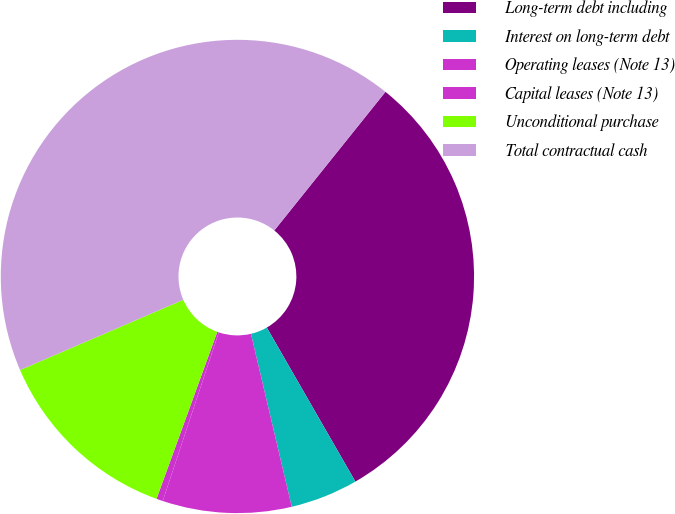<chart> <loc_0><loc_0><loc_500><loc_500><pie_chart><fcel>Long-term debt including<fcel>Interest on long-term debt<fcel>Operating leases (Note 13)<fcel>Capital leases (Note 13)<fcel>Unconditional purchase<fcel>Total contractual cash<nl><fcel>30.94%<fcel>4.62%<fcel>8.8%<fcel>0.44%<fcel>12.98%<fcel>42.23%<nl></chart> 